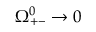<formula> <loc_0><loc_0><loc_500><loc_500>\Omega _ { + - } ^ { 0 } \rightarrow 0</formula> 